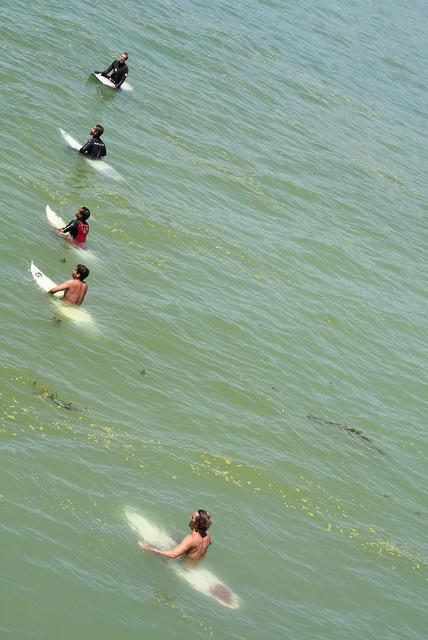Are all the people in this scene facing in the same direction?
Answer briefly. Yes. How many surfboards are on the water?
Be succinct. 5. Do all the surfers have their upper torso covered?
Be succinct. No. 